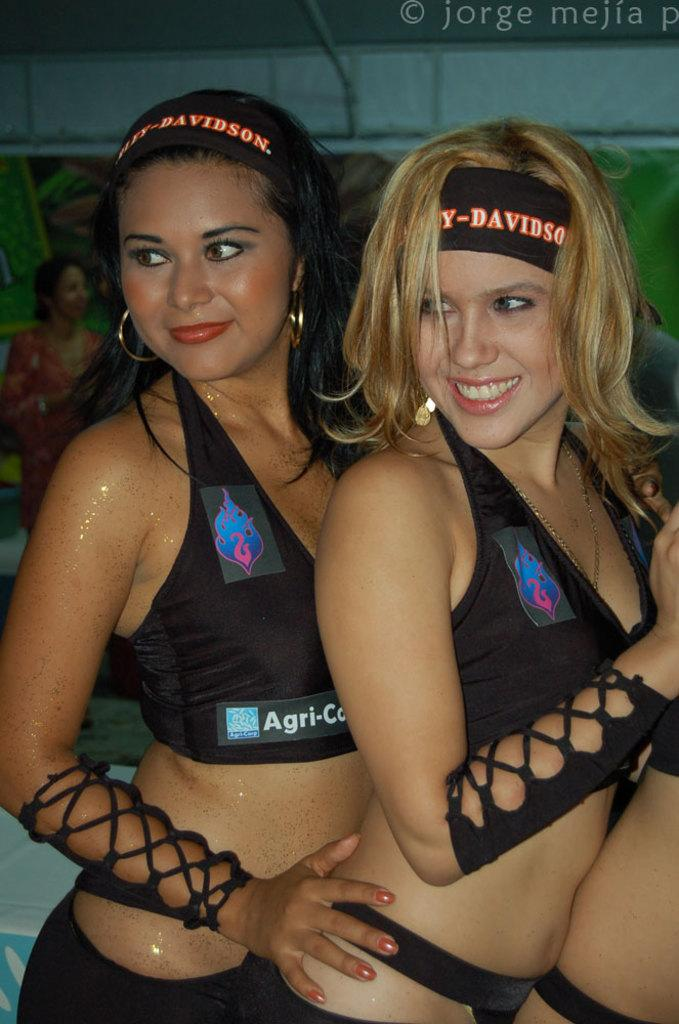<image>
Write a terse but informative summary of the picture. Two girls have on black and orange Harley Davidson headbands. 